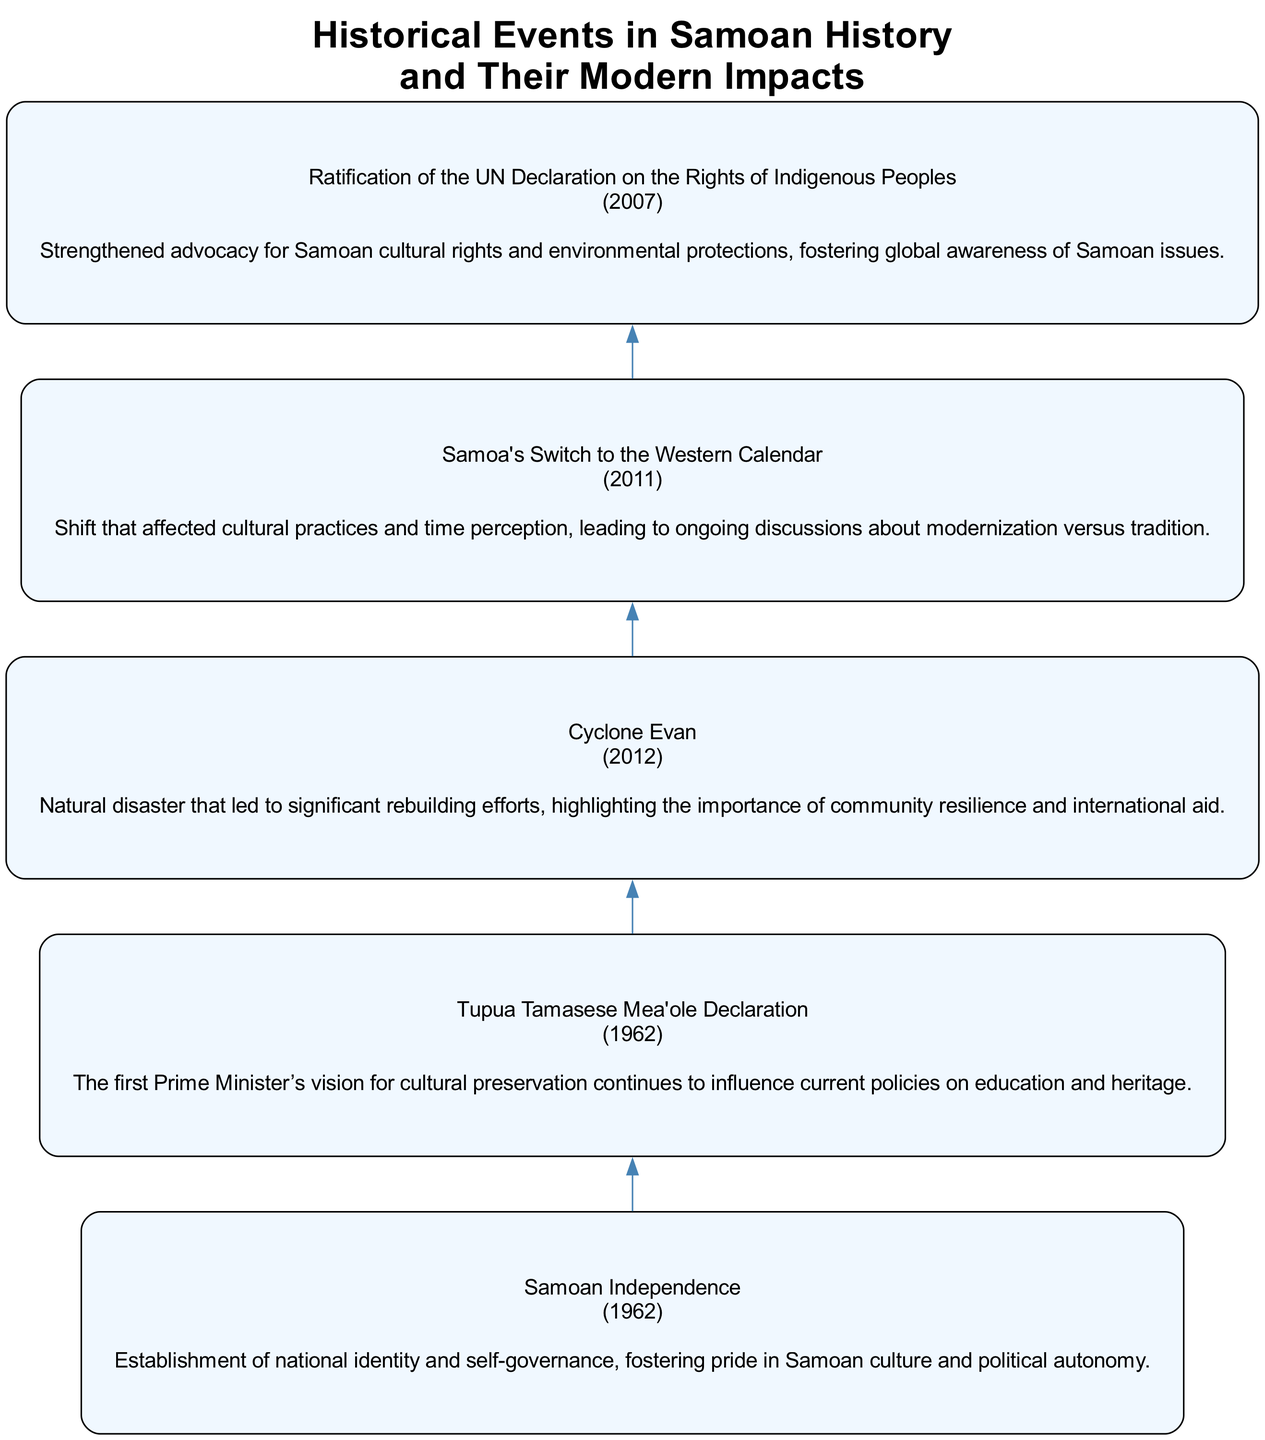What year did Samoa gain independence? The diagram clearly shows the event of Samoan Independence marked in the year 1962.
Answer: 1962 What is the impact of Samoa's switch to the Western Calendar? The diagram states that the impact of this event affected cultural practices and time perception, leading to ongoing discussions about modernization versus tradition.
Answer: Shift that affected cultural practices and time perception How many events are represented in the diagram? By counting the events listed in the diagram, we see there are five key historical events shown.
Answer: 5 What is the first event listed in the diagram? The first event in the diagram is Samoan Independence, which is listed at the top.
Answer: Samoan Independence What significant impact arose from the Ratification of the UN Declaration on the Rights of Indigenous Peoples? The diagram indicates that this event strengthened advocacy for Samoan cultural rights and environmental protections, which raises global awareness of Samoan issues.
Answer: Strengthened advocacy for Samoan cultural rights How does the impact of Cyclone Evan connect to the theme of community? The diagram links Cyclone Evan to a significant rebuilding effort, which underscores the importance of community resilience after a natural disaster.
Answer: Importance of community resilience What was a primary focus of Tupua Tamasese Mea'ole's vision as mentioned in the diagram? The diagram specifies that this vision emphasized cultural preservation, which continues to influence modern policies related to education and heritage.
Answer: Cultural preservation Which event in the diagram occurred in 2011? The diagram illustrates that the event corresponding to the year 2011 is Samoa's Switch to the Western Calendar.
Answer: Samoa's Switch to the Western Calendar What was the sequence of events leading up to Cyclone Evan? The diagram shows the progression from Samoan Independence through Tupua Tamasese Mea'ole Declaration and the Ratification of the UN Declaration on Indigenous Peoples, leading ultimately to Cyclone Evan in 2012, indicating a historical flow of events.
Answer: Samoan Independence → Tupua Tamasese Mea'ole Declaration → Ratification of the UN Declaration on Indigenous Peoples → Cyclone Evan 